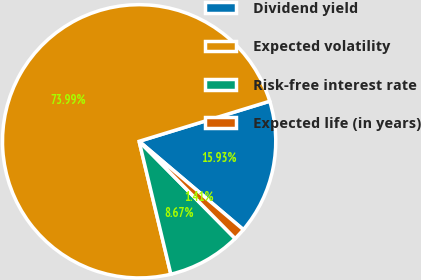<chart> <loc_0><loc_0><loc_500><loc_500><pie_chart><fcel>Dividend yield<fcel>Expected volatility<fcel>Risk-free interest rate<fcel>Expected life (in years)<nl><fcel>15.93%<fcel>73.99%<fcel>8.67%<fcel>1.41%<nl></chart> 